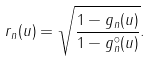Convert formula to latex. <formula><loc_0><loc_0><loc_500><loc_500>r _ { n } ( u ) = \sqrt { \frac { 1 - g _ { n } ( u ) } { 1 - { g } ^ { \circ } _ { n } ( u ) } } .</formula> 